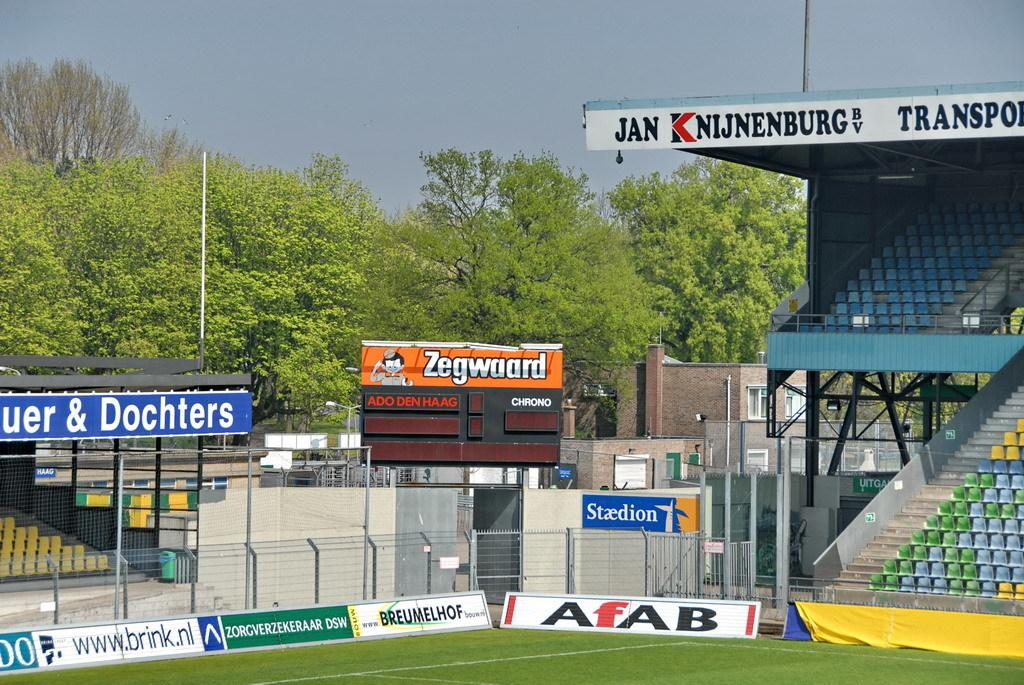<image>
Give a short and clear explanation of the subsequent image. The stadium is empty with advertisements on the side including ones for Zegwaard, AfAB, and BREUMELOF. 